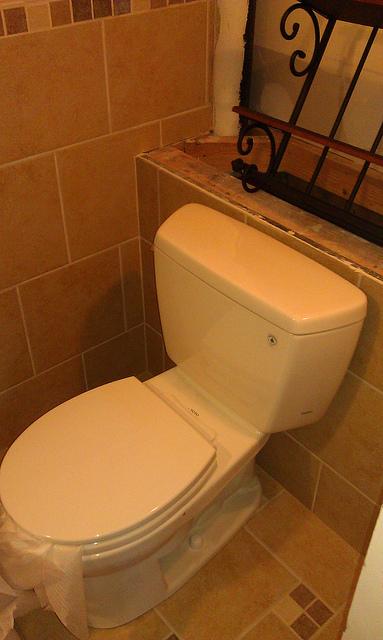What room is this?
Be succinct. Bathroom. What is hanging out of the toilet?
Quick response, please. Toilet paper. What color is the toilet?
Concise answer only. White. 